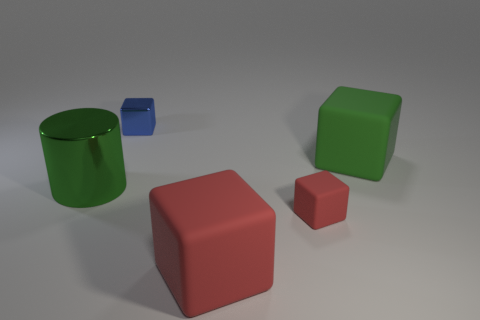Are there any small things in front of the matte cube behind the big green metallic thing?
Keep it short and to the point. Yes. How many metal cubes are left of the large thing that is behind the big metal cylinder?
Offer a very short reply. 1. There is another cube that is the same size as the metal block; what is it made of?
Provide a succinct answer. Rubber. Do the green thing right of the large green metal cylinder and the large metallic object have the same shape?
Your answer should be very brief. No. Are there more large green metallic cylinders on the right side of the cylinder than green cylinders that are on the right side of the small red rubber object?
Make the answer very short. No. How many tiny things have the same material as the large green cube?
Ensure brevity in your answer.  1. Do the blue cube and the green cube have the same size?
Offer a terse response. No. The small metal thing has what color?
Make the answer very short. Blue. How many objects are either big green objects or large red rubber things?
Your answer should be very brief. 3. Is there a blue metal thing of the same shape as the large green metallic thing?
Make the answer very short. No. 